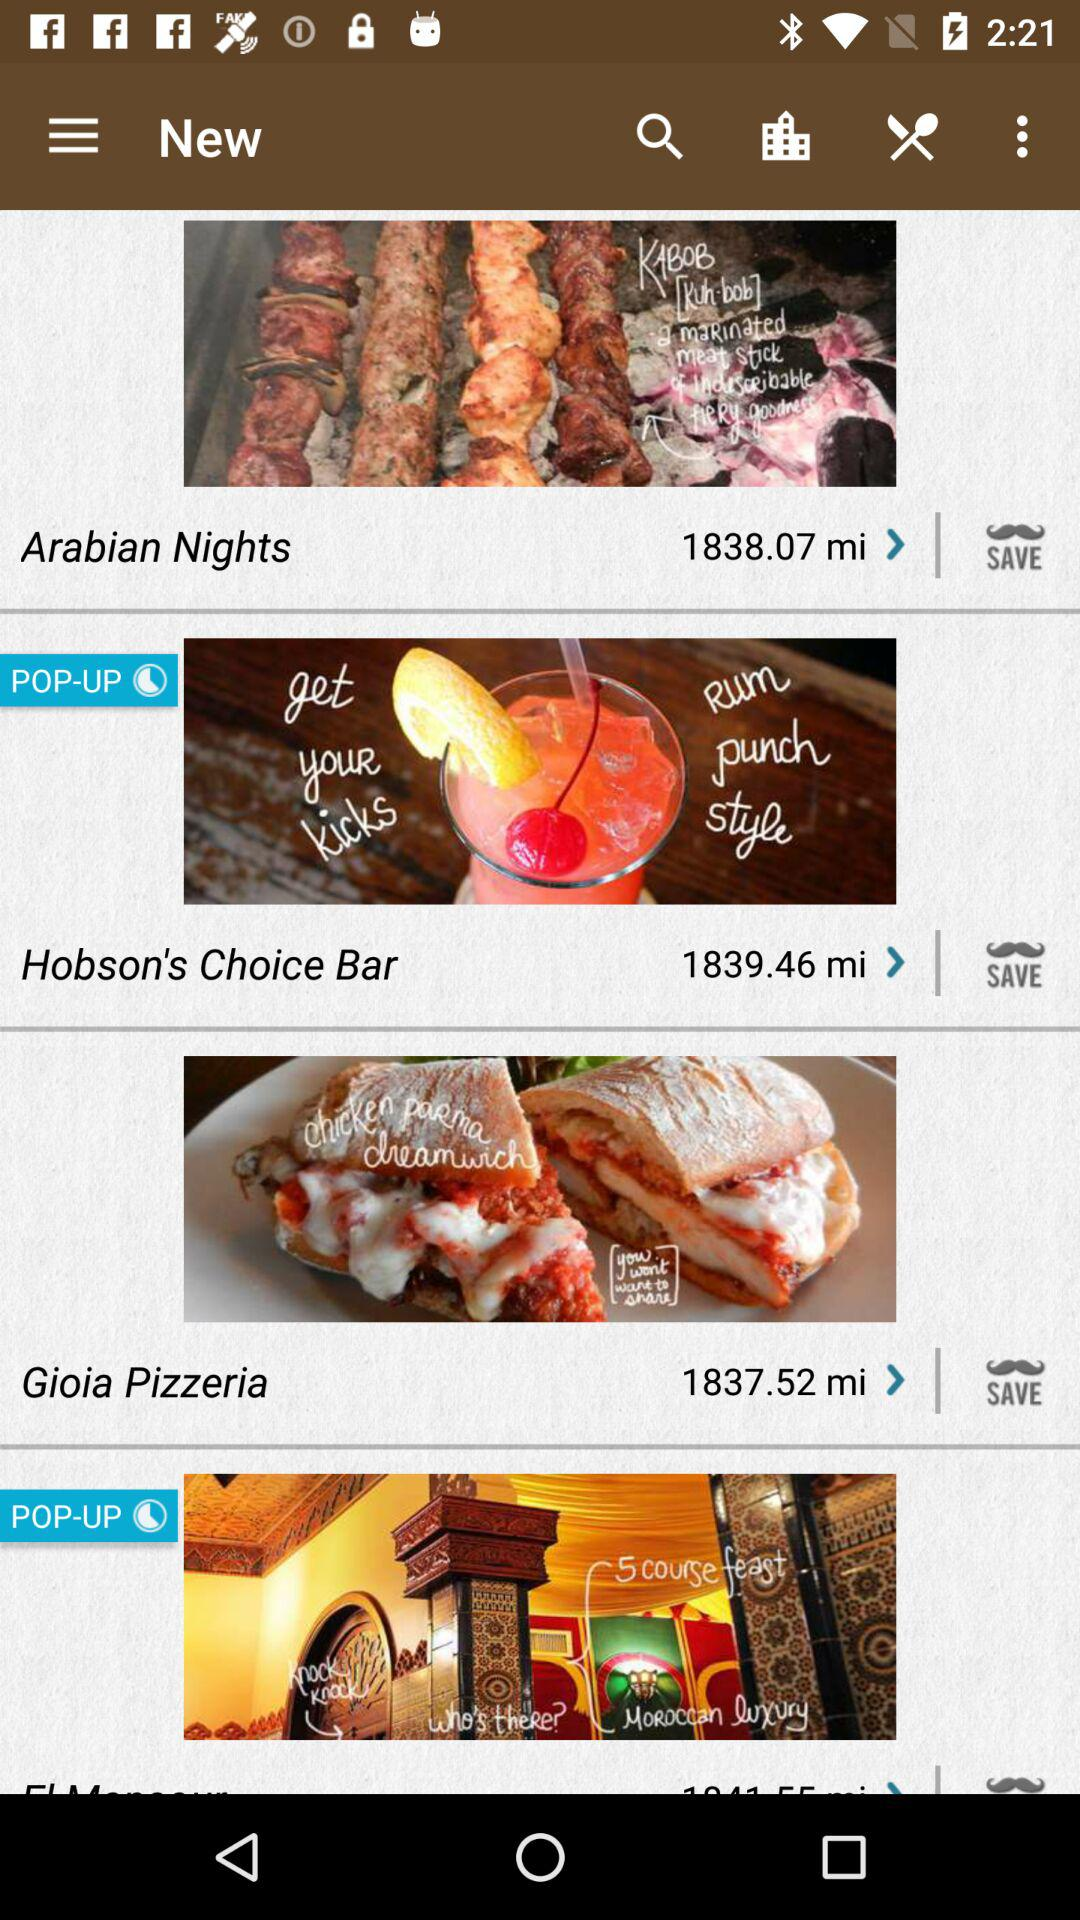How many miles away is the restaurant with the lowest distance?
Answer the question using a single word or phrase. 1837.52 